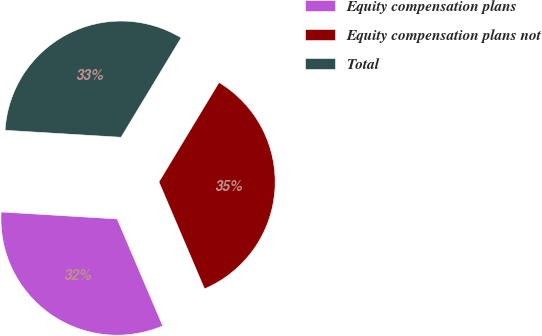<chart> <loc_0><loc_0><loc_500><loc_500><pie_chart><fcel>Equity compensation plans<fcel>Equity compensation plans not<fcel>Total<nl><fcel>32.37%<fcel>34.94%<fcel>32.69%<nl></chart> 